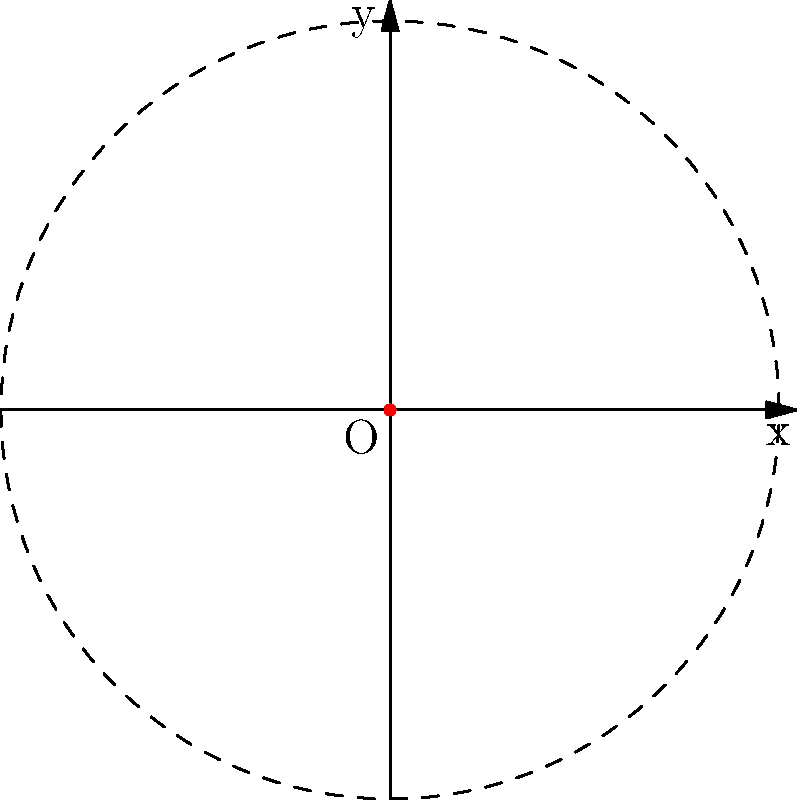Consider the Archimedean spiral given by the polar equation $r = a\theta$, where $a > 0$ is a constant. Sketch the spiral for $\theta \in [0, 4\pi]$ and determine the following:

a) The distance between successive turns of the spiral.
b) The equation of the circle that touches the outermost point of the spiral at $\theta = 4\pi$.
c) Express the arc length of the spiral from $\theta = 0$ to $\theta = 4\pi$ in terms of $a$. Let's approach this step-by-step:

a) To find the distance between successive turns, we need to consider the difference in r for a full rotation (2π):
   $r_2 - r_1 = a(\theta + 2\pi) - a\theta = 2\pi a$
   Thus, the distance between successive turns is constant and equal to $2\pi a$.

b) At $\theta = 4\pi$, the radius of the spiral is:
   $r = a(4\pi)$
   This is the radius of the circle that touches the outermost point of the spiral.
   The equation of this circle in polar form is $r = 4\pi a$.

c) To find the arc length, we use the formula for arc length in polar coordinates:
   $L = \int_0^{4\pi} \sqrt{r^2 + (\frac{dr}{d\theta})^2} d\theta$

   Here, $r = a\theta$ and $\frac{dr}{d\theta} = a$

   Substituting:
   $L = \int_0^{4\pi} \sqrt{(a\theta)^2 + a^2} d\theta$
      $= a\int_0^{4\pi} \sqrt{\theta^2 + 1} d\theta$

   This integral doesn't have an elementary antiderivative. However, it can be expressed in terms of hyperbolic functions:

   $L = \frac{a}{2}[4\pi\sqrt{(4\pi)^2 + 1} + \sinh^{-1}(4\pi)] - \frac{a}{2}[0 + \sinh^{-1}(0)]$

   $= \frac{a}{2}[4\pi\sqrt{16\pi^2 + 1} + \sinh^{-1}(4\pi)]$

This is the exact expression for the arc length in terms of $a$.
Answer: a) $2\pi a$
b) $r = 4\pi a$
c) $\frac{a}{2}[4\pi\sqrt{16\pi^2 + 1} + \sinh^{-1}(4\pi)]$ 